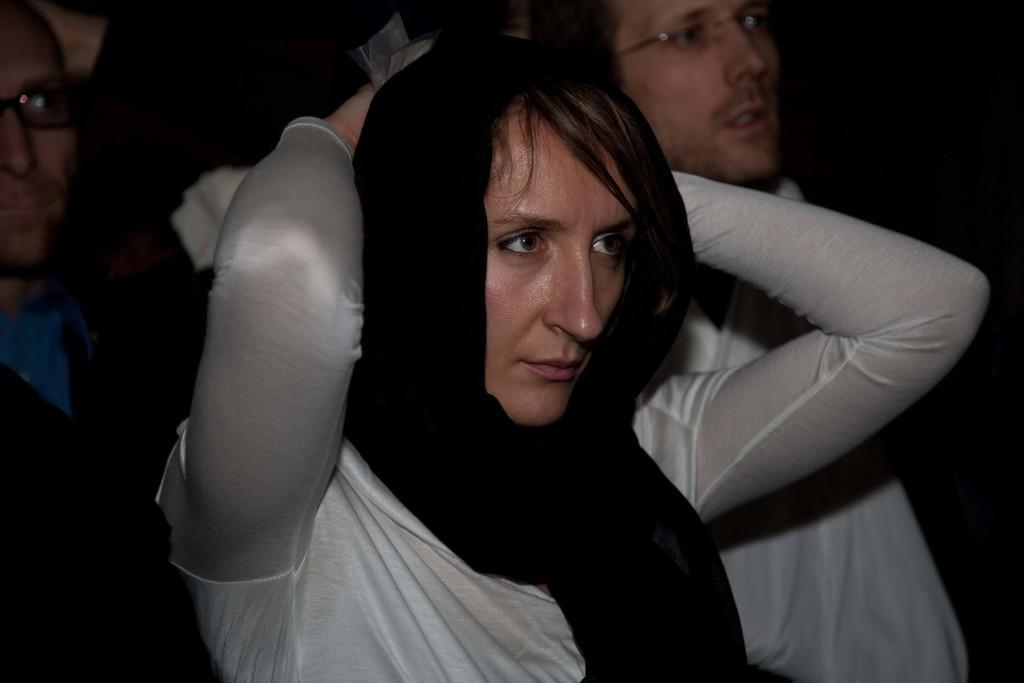Could you give a brief overview of what you see in this image? This picture shows few people standing and we see couple of men wore spectacles on their faces and a women wore black cloth on her head, 